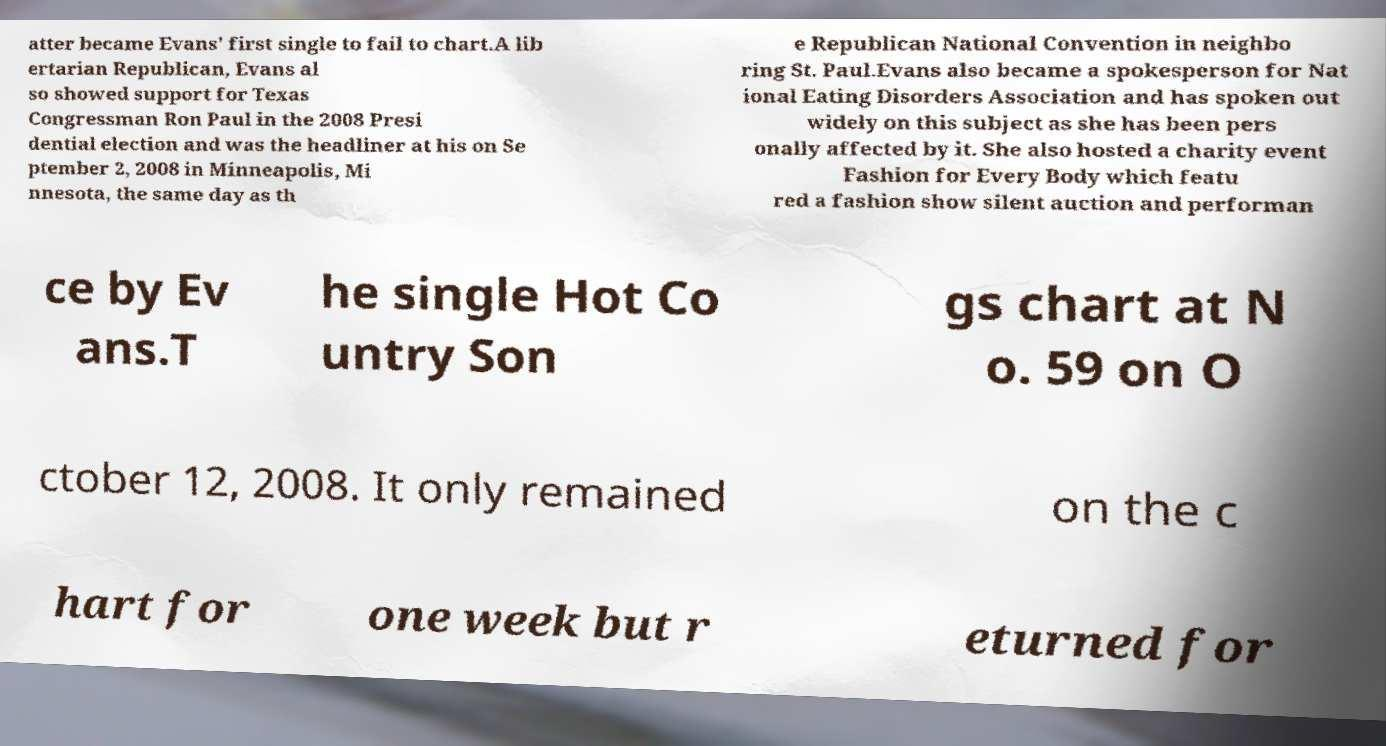Could you assist in decoding the text presented in this image and type it out clearly? atter became Evans' first single to fail to chart.A lib ertarian Republican, Evans al so showed support for Texas Congressman Ron Paul in the 2008 Presi dential election and was the headliner at his on Se ptember 2, 2008 in Minneapolis, Mi nnesota, the same day as th e Republican National Convention in neighbo ring St. Paul.Evans also became a spokesperson for Nat ional Eating Disorders Association and has spoken out widely on this subject as she has been pers onally affected by it. She also hosted a charity event Fashion for Every Body which featu red a fashion show silent auction and performan ce by Ev ans.T he single Hot Co untry Son gs chart at N o. 59 on O ctober 12, 2008. It only remained on the c hart for one week but r eturned for 